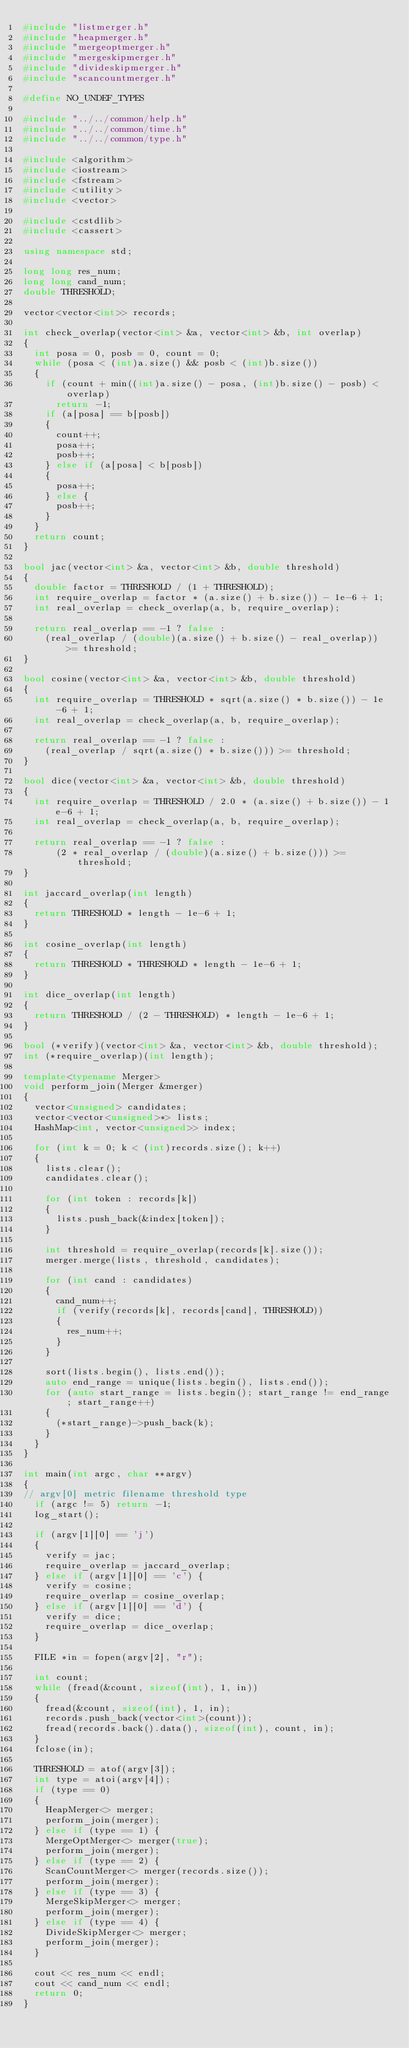<code> <loc_0><loc_0><loc_500><loc_500><_C++_>#include "listmerger.h"
#include "heapmerger.h"
#include "mergeoptmerger.h"
#include "mergeskipmerger.h"
#include "divideskipmerger.h"
#include "scancountmerger.h"

#define NO_UNDEF_TYPES

#include "../../common/help.h"
#include "../../common/time.h"
#include "../../common/type.h"

#include <algorithm>
#include <iostream>
#include <fstream>
#include <utility>
#include <vector>

#include <cstdlib>
#include <cassert>

using namespace std;

long long res_num;
long long cand_num;
double THRESHOLD;

vector<vector<int>> records;

int check_overlap(vector<int> &a, vector<int> &b, int overlap)
{
	int posa = 0, posb = 0, count = 0;
	while (posa < (int)a.size() && posb < (int)b.size())
	{
		if (count + min((int)a.size() - posa, (int)b.size() - posb) < overlap)
			return -1;
		if (a[posa] == b[posb])
		{
			count++;
			posa++;
			posb++;
		} else if (a[posa] < b[posb])
		{
			posa++;
		} else {
			posb++;
		}
	}
	return count;
}

bool jac(vector<int> &a, vector<int> &b, double threshold)
{
	double factor = THRESHOLD / (1 + THRESHOLD);
	int require_overlap = factor * (a.size() + b.size()) - 1e-6 + 1;
	int real_overlap = check_overlap(a, b, require_overlap);

	return real_overlap == -1 ? false :
		(real_overlap / (double)(a.size() + b.size() - real_overlap)) >= threshold;
}

bool cosine(vector<int> &a, vector<int> &b, double threshold)
{
	int require_overlap = THRESHOLD * sqrt(a.size() * b.size()) - 1e-6 + 1;
	int real_overlap = check_overlap(a, b, require_overlap);

	return real_overlap == -1 ? false :
		(real_overlap / sqrt(a.size() * b.size())) >= threshold;
}

bool dice(vector<int> &a, vector<int> &b, double threshold)
{
	int require_overlap = THRESHOLD / 2.0 * (a.size() + b.size()) - 1e-6 + 1;
	int real_overlap = check_overlap(a, b, require_overlap);

	return real_overlap == -1 ? false :
	    (2 * real_overlap / (double)(a.size() + b.size())) >= threshold;
}

int jaccard_overlap(int length)
{
	return THRESHOLD * length - 1e-6 + 1;
}

int cosine_overlap(int length)
{
	return THRESHOLD * THRESHOLD * length - 1e-6 + 1;
}

int dice_overlap(int length)
{
	return THRESHOLD / (2 - THRESHOLD) * length - 1e-6 + 1;
}

bool (*verify)(vector<int> &a, vector<int> &b, double threshold);
int (*require_overlap)(int length);

template<typename Merger>
void perform_join(Merger &merger)
{
	vector<unsigned> candidates;
	vector<vector<unsigned>*> lists;
	HashMap<int, vector<unsigned>> index;

	for (int k = 0; k < (int)records.size(); k++)
	{
		lists.clear();
		candidates.clear();

		for (int token : records[k])
		{
			lists.push_back(&index[token]);
		}

		int threshold = require_overlap(records[k].size());
		merger.merge(lists, threshold, candidates);

		for (int cand : candidates)
		{
			cand_num++;
			if (verify(records[k], records[cand], THRESHOLD))
			{
				res_num++;
			}
		}

		sort(lists.begin(), lists.end());
		auto end_range = unique(lists.begin(), lists.end());
		for (auto start_range = lists.begin(); start_range != end_range; start_range++)
		{
			(*start_range)->push_back(k);
		}
	}
}

int main(int argc, char **argv)
{
// argv[0] metric filename threshold type
	if (argc != 5) return -1;
	log_start();

	if (argv[1][0] == 'j')
	{
		verify = jac;
		require_overlap = jaccard_overlap;
	} else if (argv[1][0] == 'c') {
		verify = cosine;
		require_overlap = cosine_overlap;
	} else if (argv[1][0] == 'd') {
		verify = dice;
		require_overlap = dice_overlap;
	}

	FILE *in = fopen(argv[2], "r");

	int count;
	while (fread(&count, sizeof(int), 1, in))
	{
		fread(&count, sizeof(int), 1, in);
		records.push_back(vector<int>(count));
		fread(records.back().data(), sizeof(int), count, in);
	}
	fclose(in);

	THRESHOLD = atof(argv[3]);
	int type = atoi(argv[4]);
	if (type == 0)
	{
		HeapMerger<> merger;
		perform_join(merger);
	} else if (type == 1) {
		MergeOptMerger<> merger(true);
		perform_join(merger);
	} else if (type == 2) {
		ScanCountMerger<> merger(records.size());
		perform_join(merger);
	} else if (type == 3) {
		MergeSkipMerger<> merger;
		perform_join(merger);
	} else if (type == 4) {
		DivideSkipMerger<> merger;
		perform_join(merger);
	}

	cout << res_num << endl;
	cout << cand_num << endl;
	return 0;
}

</code> 